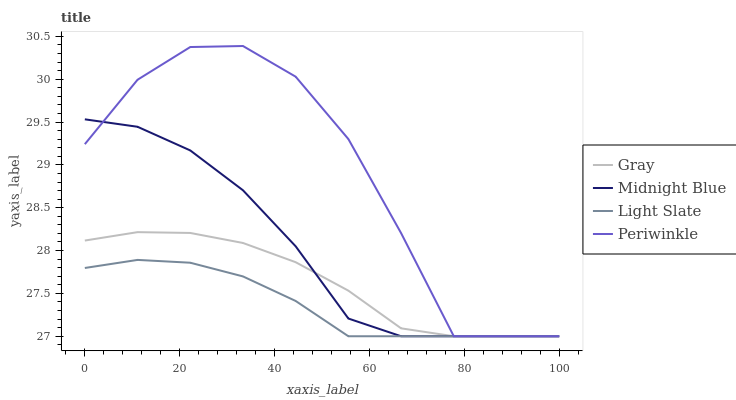Does Light Slate have the minimum area under the curve?
Answer yes or no. Yes. Does Periwinkle have the maximum area under the curve?
Answer yes or no. Yes. Does Gray have the minimum area under the curve?
Answer yes or no. No. Does Gray have the maximum area under the curve?
Answer yes or no. No. Is Light Slate the smoothest?
Answer yes or no. Yes. Is Periwinkle the roughest?
Answer yes or no. Yes. Is Gray the smoothest?
Answer yes or no. No. Is Gray the roughest?
Answer yes or no. No. Does Light Slate have the lowest value?
Answer yes or no. Yes. Does Periwinkle have the highest value?
Answer yes or no. Yes. Does Gray have the highest value?
Answer yes or no. No. Does Light Slate intersect Gray?
Answer yes or no. Yes. Is Light Slate less than Gray?
Answer yes or no. No. Is Light Slate greater than Gray?
Answer yes or no. No. 